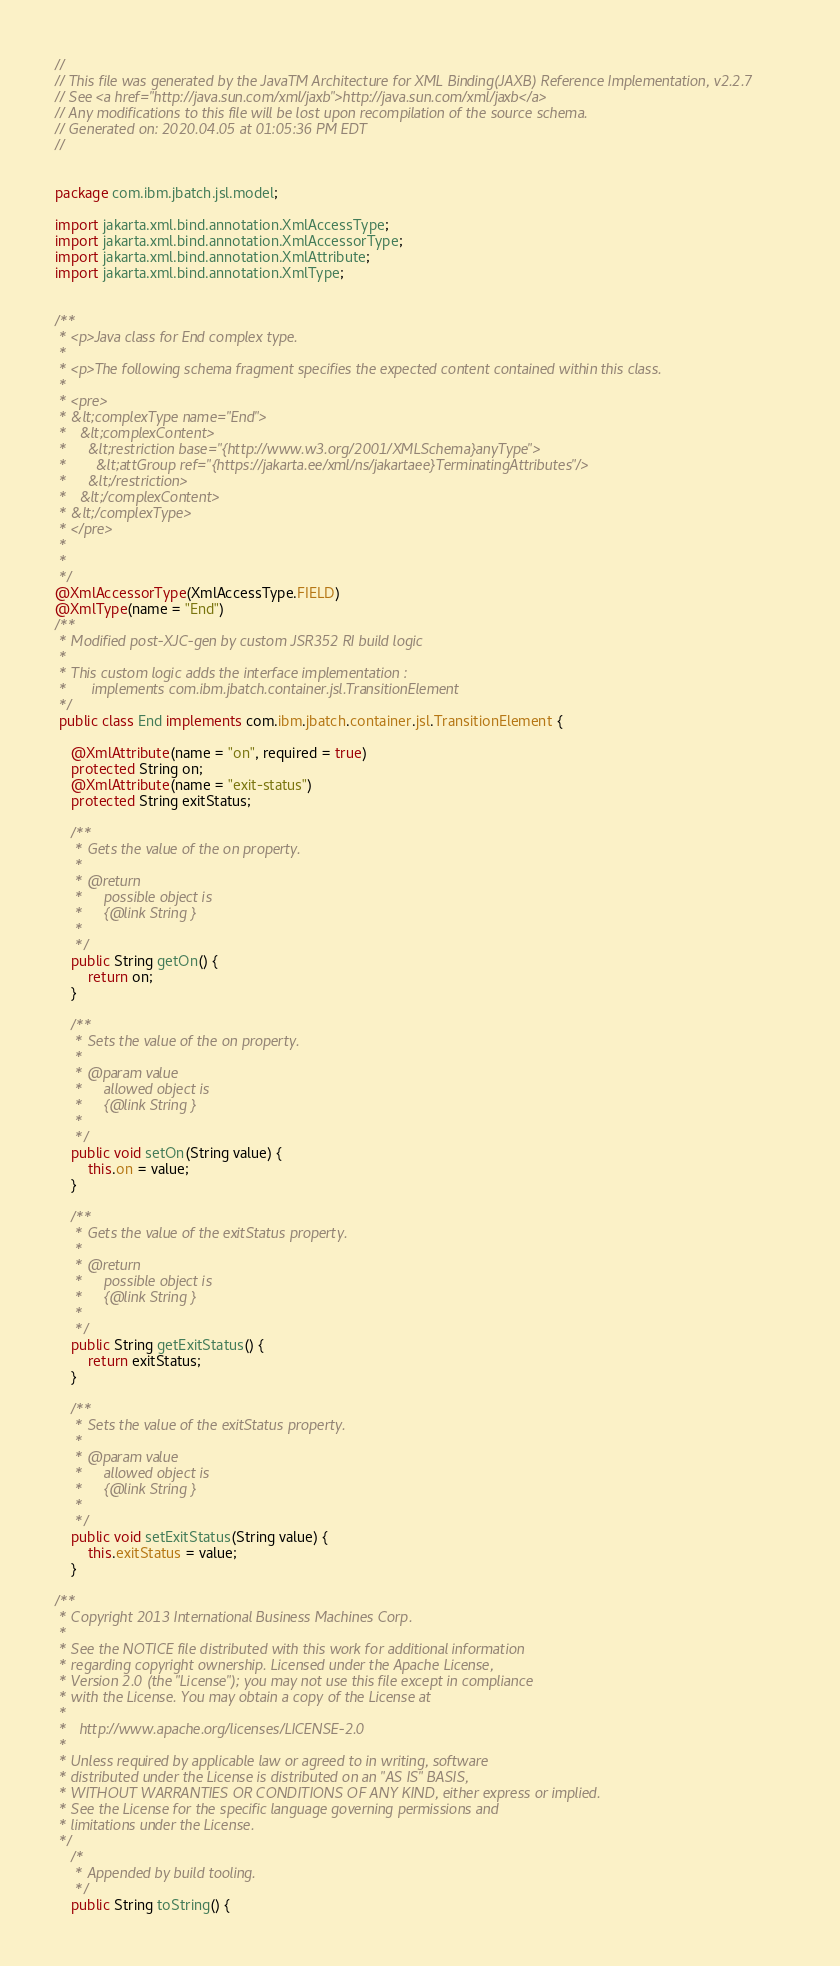<code> <loc_0><loc_0><loc_500><loc_500><_Java_>//
// This file was generated by the JavaTM Architecture for XML Binding(JAXB) Reference Implementation, v2.2.7 
// See <a href="http://java.sun.com/xml/jaxb">http://java.sun.com/xml/jaxb</a> 
// Any modifications to this file will be lost upon recompilation of the source schema. 
// Generated on: 2020.04.05 at 01:05:36 PM EDT 
//


package com.ibm.jbatch.jsl.model;

import jakarta.xml.bind.annotation.XmlAccessType;
import jakarta.xml.bind.annotation.XmlAccessorType;
import jakarta.xml.bind.annotation.XmlAttribute;
import jakarta.xml.bind.annotation.XmlType;


/**
 * <p>Java class for End complex type.
 * 
 * <p>The following schema fragment specifies the expected content contained within this class.
 * 
 * <pre>
 * &lt;complexType name="End">
 *   &lt;complexContent>
 *     &lt;restriction base="{http://www.w3.org/2001/XMLSchema}anyType">
 *       &lt;attGroup ref="{https://jakarta.ee/xml/ns/jakartaee}TerminatingAttributes"/>
 *     &lt;/restriction>
 *   &lt;/complexContent>
 * &lt;/complexType>
 * </pre>
 * 
 * 
 */
@XmlAccessorType(XmlAccessType.FIELD)
@XmlType(name = "End")
/**
 * Modified post-XJC-gen by custom JSR352 RI build logic 
 * 
 * This custom logic adds the interface implementation : 
 *      implements com.ibm.jbatch.container.jsl.TransitionElement 
 */
 public class End implements com.ibm.jbatch.container.jsl.TransitionElement {

    @XmlAttribute(name = "on", required = true)
    protected String on;
    @XmlAttribute(name = "exit-status")
    protected String exitStatus;

    /**
     * Gets the value of the on property.
     * 
     * @return
     *     possible object is
     *     {@link String }
     *     
     */
    public String getOn() {
        return on;
    }

    /**
     * Sets the value of the on property.
     * 
     * @param value
     *     allowed object is
     *     {@link String }
     *     
     */
    public void setOn(String value) {
        this.on = value;
    }

    /**
     * Gets the value of the exitStatus property.
     * 
     * @return
     *     possible object is
     *     {@link String }
     *     
     */
    public String getExitStatus() {
        return exitStatus;
    }

    /**
     * Sets the value of the exitStatus property.
     * 
     * @param value
     *     allowed object is
     *     {@link String }
     *     
     */
    public void setExitStatus(String value) {
        this.exitStatus = value;
    }

/**
 * Copyright 2013 International Business Machines Corp.
 *
 * See the NOTICE file distributed with this work for additional information
 * regarding copyright ownership. Licensed under the Apache License,
 * Version 2.0 (the "License"); you may not use this file except in compliance
 * with the License. You may obtain a copy of the License at
 *
 *   http://www.apache.org/licenses/LICENSE-2.0
 *
 * Unless required by applicable law or agreed to in writing, software
 * distributed under the License is distributed on an "AS IS" BASIS,
 * WITHOUT WARRANTIES OR CONDITIONS OF ANY KIND, either express or implied.
 * See the License for the specific language governing permissions and
 * limitations under the License.
 */
    /*
     * Appended by build tooling.
     */
	public String toString() {</code> 